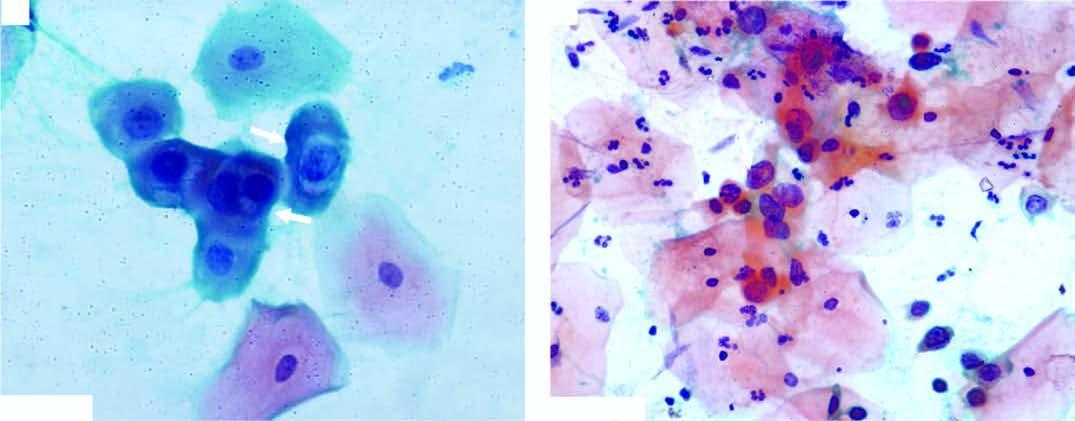does the background show numerous pmns?
Answer the question using a single word or phrase. Yes 